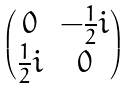Convert formula to latex. <formula><loc_0><loc_0><loc_500><loc_500>\begin{pmatrix} 0 & - \frac { 1 } { 2 } i \\ \frac { 1 } { 2 } i & 0 \end{pmatrix}</formula> 